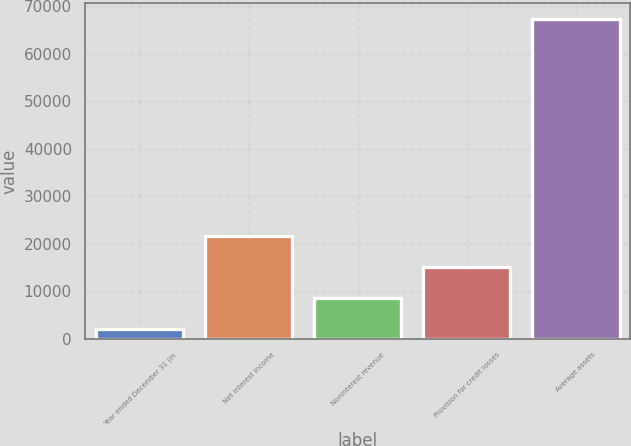Convert chart to OTSL. <chart><loc_0><loc_0><loc_500><loc_500><bar_chart><fcel>Year ended December 31 (in<fcel>Net interest income<fcel>Noninterest revenue<fcel>Provision for credit losses<fcel>Average assets<nl><fcel>2005<fcel>21557.5<fcel>8522.5<fcel>15040<fcel>67180<nl></chart> 